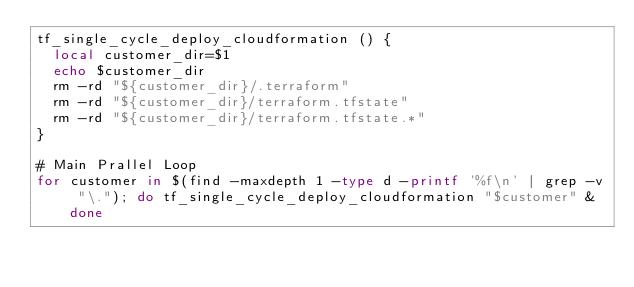<code> <loc_0><loc_0><loc_500><loc_500><_Bash_>tf_single_cycle_deploy_cloudformation () {
  local customer_dir=$1
  echo $customer_dir
  rm -rd "${customer_dir}/.terraform"
  rm -rd "${customer_dir}/terraform.tfstate"
  rm -rd "${customer_dir}/terraform.tfstate.*"
}

# Main Prallel Loop
for customer in $(find -maxdepth 1 -type d -printf '%f\n' | grep -v "\."); do tf_single_cycle_deploy_cloudformation "$customer" & done
</code> 